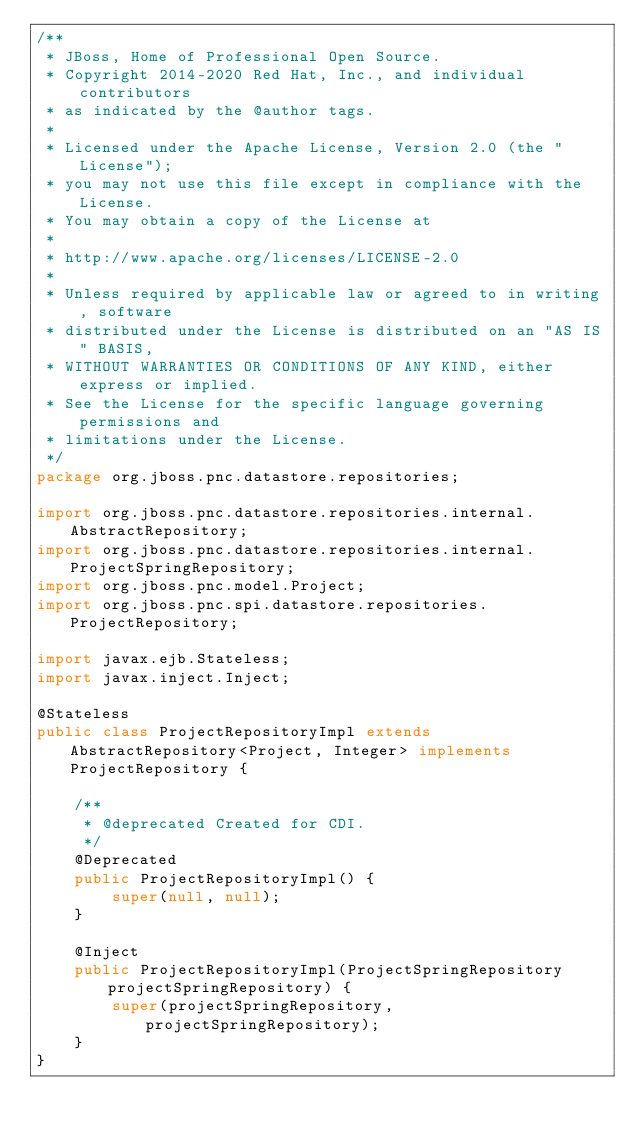Convert code to text. <code><loc_0><loc_0><loc_500><loc_500><_Java_>/**
 * JBoss, Home of Professional Open Source.
 * Copyright 2014-2020 Red Hat, Inc., and individual contributors
 * as indicated by the @author tags.
 *
 * Licensed under the Apache License, Version 2.0 (the "License");
 * you may not use this file except in compliance with the License.
 * You may obtain a copy of the License at
 *
 * http://www.apache.org/licenses/LICENSE-2.0
 *
 * Unless required by applicable law or agreed to in writing, software
 * distributed under the License is distributed on an "AS IS" BASIS,
 * WITHOUT WARRANTIES OR CONDITIONS OF ANY KIND, either express or implied.
 * See the License for the specific language governing permissions and
 * limitations under the License.
 */
package org.jboss.pnc.datastore.repositories;

import org.jboss.pnc.datastore.repositories.internal.AbstractRepository;
import org.jboss.pnc.datastore.repositories.internal.ProjectSpringRepository;
import org.jboss.pnc.model.Project;
import org.jboss.pnc.spi.datastore.repositories.ProjectRepository;

import javax.ejb.Stateless;
import javax.inject.Inject;

@Stateless
public class ProjectRepositoryImpl extends AbstractRepository<Project, Integer> implements ProjectRepository {

    /**
     * @deprecated Created for CDI.
     */
    @Deprecated
    public ProjectRepositoryImpl() {
        super(null, null);
    }

    @Inject
    public ProjectRepositoryImpl(ProjectSpringRepository projectSpringRepository) {
        super(projectSpringRepository, projectSpringRepository);
    }
}
</code> 